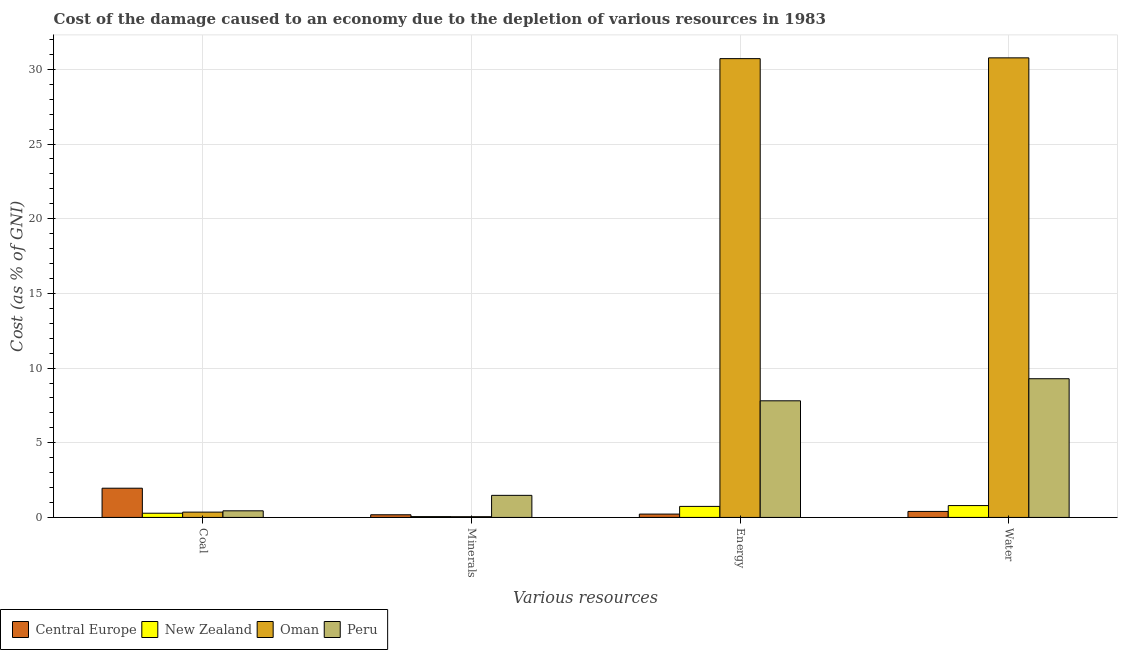How many different coloured bars are there?
Provide a succinct answer. 4. Are the number of bars per tick equal to the number of legend labels?
Keep it short and to the point. Yes. Are the number of bars on each tick of the X-axis equal?
Keep it short and to the point. Yes. What is the label of the 2nd group of bars from the left?
Your answer should be very brief. Minerals. What is the cost of damage due to depletion of water in Central Europe?
Your answer should be very brief. 0.4. Across all countries, what is the maximum cost of damage due to depletion of minerals?
Make the answer very short. 1.48. Across all countries, what is the minimum cost of damage due to depletion of minerals?
Ensure brevity in your answer.  0.05. In which country was the cost of damage due to depletion of water minimum?
Ensure brevity in your answer.  Central Europe. What is the total cost of damage due to depletion of minerals in the graph?
Your answer should be compact. 1.76. What is the difference between the cost of damage due to depletion of coal in Peru and that in New Zealand?
Make the answer very short. 0.16. What is the difference between the cost of damage due to depletion of minerals in Peru and the cost of damage due to depletion of water in Central Europe?
Offer a very short reply. 1.08. What is the average cost of damage due to depletion of water per country?
Your response must be concise. 10.31. What is the difference between the cost of damage due to depletion of coal and cost of damage due to depletion of minerals in Oman?
Your response must be concise. 0.31. In how many countries, is the cost of damage due to depletion of water greater than 7 %?
Offer a very short reply. 2. What is the ratio of the cost of damage due to depletion of energy in New Zealand to that in Oman?
Provide a succinct answer. 0.02. Is the cost of damage due to depletion of coal in New Zealand less than that in Oman?
Keep it short and to the point. Yes. Is the difference between the cost of damage due to depletion of coal in New Zealand and Oman greater than the difference between the cost of damage due to depletion of energy in New Zealand and Oman?
Offer a very short reply. Yes. What is the difference between the highest and the second highest cost of damage due to depletion of water?
Your answer should be compact. 21.48. What is the difference between the highest and the lowest cost of damage due to depletion of water?
Make the answer very short. 30.37. In how many countries, is the cost of damage due to depletion of coal greater than the average cost of damage due to depletion of coal taken over all countries?
Provide a succinct answer. 1. Is it the case that in every country, the sum of the cost of damage due to depletion of coal and cost of damage due to depletion of minerals is greater than the sum of cost of damage due to depletion of energy and cost of damage due to depletion of water?
Give a very brief answer. No. What does the 4th bar from the left in Minerals represents?
Your answer should be very brief. Peru. What does the 1st bar from the right in Coal represents?
Keep it short and to the point. Peru. Is it the case that in every country, the sum of the cost of damage due to depletion of coal and cost of damage due to depletion of minerals is greater than the cost of damage due to depletion of energy?
Provide a succinct answer. No. How many bars are there?
Offer a terse response. 16. Are all the bars in the graph horizontal?
Ensure brevity in your answer.  No. What is the title of the graph?
Ensure brevity in your answer.  Cost of the damage caused to an economy due to the depletion of various resources in 1983 . Does "Botswana" appear as one of the legend labels in the graph?
Provide a short and direct response. No. What is the label or title of the X-axis?
Ensure brevity in your answer.  Various resources. What is the label or title of the Y-axis?
Keep it short and to the point. Cost (as % of GNI). What is the Cost (as % of GNI) in Central Europe in Coal?
Your response must be concise. 1.96. What is the Cost (as % of GNI) of New Zealand in Coal?
Keep it short and to the point. 0.28. What is the Cost (as % of GNI) in Oman in Coal?
Offer a terse response. 0.36. What is the Cost (as % of GNI) of Peru in Coal?
Ensure brevity in your answer.  0.44. What is the Cost (as % of GNI) of Central Europe in Minerals?
Your answer should be compact. 0.18. What is the Cost (as % of GNI) of New Zealand in Minerals?
Keep it short and to the point. 0.06. What is the Cost (as % of GNI) of Oman in Minerals?
Your response must be concise. 0.05. What is the Cost (as % of GNI) of Peru in Minerals?
Ensure brevity in your answer.  1.48. What is the Cost (as % of GNI) in Central Europe in Energy?
Your response must be concise. 0.22. What is the Cost (as % of GNI) of New Zealand in Energy?
Your answer should be very brief. 0.74. What is the Cost (as % of GNI) in Oman in Energy?
Give a very brief answer. 30.72. What is the Cost (as % of GNI) in Peru in Energy?
Provide a short and direct response. 7.81. What is the Cost (as % of GNI) of Central Europe in Water?
Your answer should be very brief. 0.4. What is the Cost (as % of GNI) of New Zealand in Water?
Your answer should be compact. 0.79. What is the Cost (as % of GNI) in Oman in Water?
Give a very brief answer. 30.77. What is the Cost (as % of GNI) of Peru in Water?
Your response must be concise. 9.29. Across all Various resources, what is the maximum Cost (as % of GNI) of Central Europe?
Make the answer very short. 1.96. Across all Various resources, what is the maximum Cost (as % of GNI) in New Zealand?
Provide a short and direct response. 0.79. Across all Various resources, what is the maximum Cost (as % of GNI) in Oman?
Offer a very short reply. 30.77. Across all Various resources, what is the maximum Cost (as % of GNI) in Peru?
Provide a succinct answer. 9.29. Across all Various resources, what is the minimum Cost (as % of GNI) in Central Europe?
Your answer should be compact. 0.18. Across all Various resources, what is the minimum Cost (as % of GNI) in New Zealand?
Your response must be concise. 0.06. Across all Various resources, what is the minimum Cost (as % of GNI) of Oman?
Give a very brief answer. 0.05. Across all Various resources, what is the minimum Cost (as % of GNI) of Peru?
Your answer should be very brief. 0.44. What is the total Cost (as % of GNI) in Central Europe in the graph?
Offer a very short reply. 2.76. What is the total Cost (as % of GNI) of New Zealand in the graph?
Ensure brevity in your answer.  1.87. What is the total Cost (as % of GNI) of Oman in the graph?
Your response must be concise. 61.89. What is the total Cost (as % of GNI) in Peru in the graph?
Your answer should be compact. 19.01. What is the difference between the Cost (as % of GNI) in Central Europe in Coal and that in Minerals?
Give a very brief answer. 1.78. What is the difference between the Cost (as % of GNI) in New Zealand in Coal and that in Minerals?
Your answer should be very brief. 0.23. What is the difference between the Cost (as % of GNI) in Oman in Coal and that in Minerals?
Make the answer very short. 0.31. What is the difference between the Cost (as % of GNI) in Peru in Coal and that in Minerals?
Provide a succinct answer. -1.04. What is the difference between the Cost (as % of GNI) in Central Europe in Coal and that in Energy?
Your answer should be compact. 1.73. What is the difference between the Cost (as % of GNI) of New Zealand in Coal and that in Energy?
Give a very brief answer. -0.46. What is the difference between the Cost (as % of GNI) of Oman in Coal and that in Energy?
Keep it short and to the point. -30.36. What is the difference between the Cost (as % of GNI) of Peru in Coal and that in Energy?
Provide a succinct answer. -7.37. What is the difference between the Cost (as % of GNI) in Central Europe in Coal and that in Water?
Provide a short and direct response. 1.55. What is the difference between the Cost (as % of GNI) of New Zealand in Coal and that in Water?
Offer a terse response. -0.51. What is the difference between the Cost (as % of GNI) in Oman in Coal and that in Water?
Your answer should be very brief. -30.41. What is the difference between the Cost (as % of GNI) of Peru in Coal and that in Water?
Your response must be concise. -8.84. What is the difference between the Cost (as % of GNI) of Central Europe in Minerals and that in Energy?
Make the answer very short. -0.05. What is the difference between the Cost (as % of GNI) of New Zealand in Minerals and that in Energy?
Ensure brevity in your answer.  -0.68. What is the difference between the Cost (as % of GNI) of Oman in Minerals and that in Energy?
Your answer should be very brief. -30.67. What is the difference between the Cost (as % of GNI) in Peru in Minerals and that in Energy?
Make the answer very short. -6.33. What is the difference between the Cost (as % of GNI) of Central Europe in Minerals and that in Water?
Ensure brevity in your answer.  -0.22. What is the difference between the Cost (as % of GNI) of New Zealand in Minerals and that in Water?
Keep it short and to the point. -0.74. What is the difference between the Cost (as % of GNI) of Oman in Minerals and that in Water?
Give a very brief answer. -30.72. What is the difference between the Cost (as % of GNI) in Peru in Minerals and that in Water?
Keep it short and to the point. -7.81. What is the difference between the Cost (as % of GNI) in Central Europe in Energy and that in Water?
Provide a short and direct response. -0.18. What is the difference between the Cost (as % of GNI) of New Zealand in Energy and that in Water?
Keep it short and to the point. -0.06. What is the difference between the Cost (as % of GNI) in Oman in Energy and that in Water?
Give a very brief answer. -0.05. What is the difference between the Cost (as % of GNI) of Peru in Energy and that in Water?
Offer a very short reply. -1.48. What is the difference between the Cost (as % of GNI) of Central Europe in Coal and the Cost (as % of GNI) of New Zealand in Minerals?
Make the answer very short. 1.9. What is the difference between the Cost (as % of GNI) in Central Europe in Coal and the Cost (as % of GNI) in Oman in Minerals?
Keep it short and to the point. 1.91. What is the difference between the Cost (as % of GNI) in Central Europe in Coal and the Cost (as % of GNI) in Peru in Minerals?
Provide a succinct answer. 0.48. What is the difference between the Cost (as % of GNI) of New Zealand in Coal and the Cost (as % of GNI) of Oman in Minerals?
Keep it short and to the point. 0.23. What is the difference between the Cost (as % of GNI) in New Zealand in Coal and the Cost (as % of GNI) in Peru in Minerals?
Offer a terse response. -1.2. What is the difference between the Cost (as % of GNI) in Oman in Coal and the Cost (as % of GNI) in Peru in Minerals?
Provide a short and direct response. -1.12. What is the difference between the Cost (as % of GNI) in Central Europe in Coal and the Cost (as % of GNI) in New Zealand in Energy?
Your answer should be very brief. 1.22. What is the difference between the Cost (as % of GNI) of Central Europe in Coal and the Cost (as % of GNI) of Oman in Energy?
Offer a very short reply. -28.76. What is the difference between the Cost (as % of GNI) of Central Europe in Coal and the Cost (as % of GNI) of Peru in Energy?
Make the answer very short. -5.85. What is the difference between the Cost (as % of GNI) of New Zealand in Coal and the Cost (as % of GNI) of Oman in Energy?
Your response must be concise. -30.44. What is the difference between the Cost (as % of GNI) in New Zealand in Coal and the Cost (as % of GNI) in Peru in Energy?
Provide a short and direct response. -7.53. What is the difference between the Cost (as % of GNI) in Oman in Coal and the Cost (as % of GNI) in Peru in Energy?
Keep it short and to the point. -7.45. What is the difference between the Cost (as % of GNI) of Central Europe in Coal and the Cost (as % of GNI) of New Zealand in Water?
Provide a short and direct response. 1.16. What is the difference between the Cost (as % of GNI) in Central Europe in Coal and the Cost (as % of GNI) in Oman in Water?
Provide a short and direct response. -28.81. What is the difference between the Cost (as % of GNI) in Central Europe in Coal and the Cost (as % of GNI) in Peru in Water?
Provide a short and direct response. -7.33. What is the difference between the Cost (as % of GNI) of New Zealand in Coal and the Cost (as % of GNI) of Oman in Water?
Your answer should be compact. -30.49. What is the difference between the Cost (as % of GNI) in New Zealand in Coal and the Cost (as % of GNI) in Peru in Water?
Your response must be concise. -9. What is the difference between the Cost (as % of GNI) in Oman in Coal and the Cost (as % of GNI) in Peru in Water?
Give a very brief answer. -8.93. What is the difference between the Cost (as % of GNI) in Central Europe in Minerals and the Cost (as % of GNI) in New Zealand in Energy?
Ensure brevity in your answer.  -0.56. What is the difference between the Cost (as % of GNI) in Central Europe in Minerals and the Cost (as % of GNI) in Oman in Energy?
Provide a succinct answer. -30.54. What is the difference between the Cost (as % of GNI) of Central Europe in Minerals and the Cost (as % of GNI) of Peru in Energy?
Ensure brevity in your answer.  -7.63. What is the difference between the Cost (as % of GNI) of New Zealand in Minerals and the Cost (as % of GNI) of Oman in Energy?
Make the answer very short. -30.66. What is the difference between the Cost (as % of GNI) of New Zealand in Minerals and the Cost (as % of GNI) of Peru in Energy?
Give a very brief answer. -7.75. What is the difference between the Cost (as % of GNI) of Oman in Minerals and the Cost (as % of GNI) of Peru in Energy?
Offer a very short reply. -7.76. What is the difference between the Cost (as % of GNI) in Central Europe in Minerals and the Cost (as % of GNI) in New Zealand in Water?
Provide a short and direct response. -0.62. What is the difference between the Cost (as % of GNI) in Central Europe in Minerals and the Cost (as % of GNI) in Oman in Water?
Provide a short and direct response. -30.59. What is the difference between the Cost (as % of GNI) in Central Europe in Minerals and the Cost (as % of GNI) in Peru in Water?
Make the answer very short. -9.11. What is the difference between the Cost (as % of GNI) in New Zealand in Minerals and the Cost (as % of GNI) in Oman in Water?
Provide a succinct answer. -30.71. What is the difference between the Cost (as % of GNI) in New Zealand in Minerals and the Cost (as % of GNI) in Peru in Water?
Keep it short and to the point. -9.23. What is the difference between the Cost (as % of GNI) of Oman in Minerals and the Cost (as % of GNI) of Peru in Water?
Offer a very short reply. -9.24. What is the difference between the Cost (as % of GNI) in Central Europe in Energy and the Cost (as % of GNI) in New Zealand in Water?
Give a very brief answer. -0.57. What is the difference between the Cost (as % of GNI) of Central Europe in Energy and the Cost (as % of GNI) of Oman in Water?
Your answer should be compact. -30.55. What is the difference between the Cost (as % of GNI) in Central Europe in Energy and the Cost (as % of GNI) in Peru in Water?
Offer a very short reply. -9.06. What is the difference between the Cost (as % of GNI) in New Zealand in Energy and the Cost (as % of GNI) in Oman in Water?
Offer a terse response. -30.03. What is the difference between the Cost (as % of GNI) of New Zealand in Energy and the Cost (as % of GNI) of Peru in Water?
Provide a succinct answer. -8.55. What is the difference between the Cost (as % of GNI) in Oman in Energy and the Cost (as % of GNI) in Peru in Water?
Make the answer very short. 21.43. What is the average Cost (as % of GNI) in Central Europe per Various resources?
Offer a very short reply. 0.69. What is the average Cost (as % of GNI) in New Zealand per Various resources?
Provide a succinct answer. 0.47. What is the average Cost (as % of GNI) of Oman per Various resources?
Your answer should be very brief. 15.47. What is the average Cost (as % of GNI) of Peru per Various resources?
Keep it short and to the point. 4.75. What is the difference between the Cost (as % of GNI) of Central Europe and Cost (as % of GNI) of New Zealand in Coal?
Provide a succinct answer. 1.67. What is the difference between the Cost (as % of GNI) in Central Europe and Cost (as % of GNI) in Oman in Coal?
Your answer should be very brief. 1.6. What is the difference between the Cost (as % of GNI) of Central Europe and Cost (as % of GNI) of Peru in Coal?
Ensure brevity in your answer.  1.51. What is the difference between the Cost (as % of GNI) of New Zealand and Cost (as % of GNI) of Oman in Coal?
Keep it short and to the point. -0.07. What is the difference between the Cost (as % of GNI) in New Zealand and Cost (as % of GNI) in Peru in Coal?
Provide a short and direct response. -0.16. What is the difference between the Cost (as % of GNI) of Oman and Cost (as % of GNI) of Peru in Coal?
Offer a very short reply. -0.09. What is the difference between the Cost (as % of GNI) of Central Europe and Cost (as % of GNI) of New Zealand in Minerals?
Keep it short and to the point. 0.12. What is the difference between the Cost (as % of GNI) in Central Europe and Cost (as % of GNI) in Oman in Minerals?
Your answer should be compact. 0.13. What is the difference between the Cost (as % of GNI) in Central Europe and Cost (as % of GNI) in Peru in Minerals?
Provide a short and direct response. -1.3. What is the difference between the Cost (as % of GNI) in New Zealand and Cost (as % of GNI) in Oman in Minerals?
Offer a terse response. 0.01. What is the difference between the Cost (as % of GNI) in New Zealand and Cost (as % of GNI) in Peru in Minerals?
Make the answer very short. -1.42. What is the difference between the Cost (as % of GNI) of Oman and Cost (as % of GNI) of Peru in Minerals?
Offer a terse response. -1.43. What is the difference between the Cost (as % of GNI) in Central Europe and Cost (as % of GNI) in New Zealand in Energy?
Offer a very short reply. -0.52. What is the difference between the Cost (as % of GNI) of Central Europe and Cost (as % of GNI) of Oman in Energy?
Ensure brevity in your answer.  -30.49. What is the difference between the Cost (as % of GNI) of Central Europe and Cost (as % of GNI) of Peru in Energy?
Make the answer very short. -7.58. What is the difference between the Cost (as % of GNI) in New Zealand and Cost (as % of GNI) in Oman in Energy?
Make the answer very short. -29.98. What is the difference between the Cost (as % of GNI) of New Zealand and Cost (as % of GNI) of Peru in Energy?
Your answer should be compact. -7.07. What is the difference between the Cost (as % of GNI) in Oman and Cost (as % of GNI) in Peru in Energy?
Keep it short and to the point. 22.91. What is the difference between the Cost (as % of GNI) in Central Europe and Cost (as % of GNI) in New Zealand in Water?
Offer a terse response. -0.39. What is the difference between the Cost (as % of GNI) in Central Europe and Cost (as % of GNI) in Oman in Water?
Keep it short and to the point. -30.37. What is the difference between the Cost (as % of GNI) in Central Europe and Cost (as % of GNI) in Peru in Water?
Provide a short and direct response. -8.88. What is the difference between the Cost (as % of GNI) of New Zealand and Cost (as % of GNI) of Oman in Water?
Give a very brief answer. -29.98. What is the difference between the Cost (as % of GNI) in New Zealand and Cost (as % of GNI) in Peru in Water?
Offer a very short reply. -8.49. What is the difference between the Cost (as % of GNI) of Oman and Cost (as % of GNI) of Peru in Water?
Your answer should be very brief. 21.48. What is the ratio of the Cost (as % of GNI) of Central Europe in Coal to that in Minerals?
Your answer should be very brief. 11. What is the ratio of the Cost (as % of GNI) of New Zealand in Coal to that in Minerals?
Make the answer very short. 5.11. What is the ratio of the Cost (as % of GNI) of Oman in Coal to that in Minerals?
Provide a succinct answer. 7.31. What is the ratio of the Cost (as % of GNI) in Peru in Coal to that in Minerals?
Give a very brief answer. 0.3. What is the ratio of the Cost (as % of GNI) in Central Europe in Coal to that in Energy?
Provide a succinct answer. 8.76. What is the ratio of the Cost (as % of GNI) of New Zealand in Coal to that in Energy?
Offer a terse response. 0.38. What is the ratio of the Cost (as % of GNI) in Oman in Coal to that in Energy?
Provide a short and direct response. 0.01. What is the ratio of the Cost (as % of GNI) in Peru in Coal to that in Energy?
Offer a terse response. 0.06. What is the ratio of the Cost (as % of GNI) in Central Europe in Coal to that in Water?
Make the answer very short. 4.88. What is the ratio of the Cost (as % of GNI) of New Zealand in Coal to that in Water?
Make the answer very short. 0.35. What is the ratio of the Cost (as % of GNI) of Oman in Coal to that in Water?
Give a very brief answer. 0.01. What is the ratio of the Cost (as % of GNI) in Peru in Coal to that in Water?
Your answer should be compact. 0.05. What is the ratio of the Cost (as % of GNI) in Central Europe in Minerals to that in Energy?
Provide a short and direct response. 0.8. What is the ratio of the Cost (as % of GNI) of New Zealand in Minerals to that in Energy?
Give a very brief answer. 0.07. What is the ratio of the Cost (as % of GNI) in Oman in Minerals to that in Energy?
Make the answer very short. 0. What is the ratio of the Cost (as % of GNI) in Peru in Minerals to that in Energy?
Keep it short and to the point. 0.19. What is the ratio of the Cost (as % of GNI) of Central Europe in Minerals to that in Water?
Keep it short and to the point. 0.44. What is the ratio of the Cost (as % of GNI) in New Zealand in Minerals to that in Water?
Your response must be concise. 0.07. What is the ratio of the Cost (as % of GNI) of Oman in Minerals to that in Water?
Your response must be concise. 0. What is the ratio of the Cost (as % of GNI) of Peru in Minerals to that in Water?
Your answer should be very brief. 0.16. What is the ratio of the Cost (as % of GNI) of Central Europe in Energy to that in Water?
Provide a short and direct response. 0.56. What is the ratio of the Cost (as % of GNI) of New Zealand in Energy to that in Water?
Give a very brief answer. 0.93. What is the ratio of the Cost (as % of GNI) of Peru in Energy to that in Water?
Give a very brief answer. 0.84. What is the difference between the highest and the second highest Cost (as % of GNI) in Central Europe?
Keep it short and to the point. 1.55. What is the difference between the highest and the second highest Cost (as % of GNI) of New Zealand?
Provide a short and direct response. 0.06. What is the difference between the highest and the second highest Cost (as % of GNI) in Oman?
Keep it short and to the point. 0.05. What is the difference between the highest and the second highest Cost (as % of GNI) in Peru?
Offer a very short reply. 1.48. What is the difference between the highest and the lowest Cost (as % of GNI) of Central Europe?
Ensure brevity in your answer.  1.78. What is the difference between the highest and the lowest Cost (as % of GNI) of New Zealand?
Make the answer very short. 0.74. What is the difference between the highest and the lowest Cost (as % of GNI) of Oman?
Provide a succinct answer. 30.72. What is the difference between the highest and the lowest Cost (as % of GNI) in Peru?
Give a very brief answer. 8.84. 